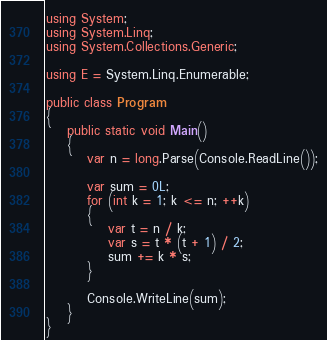Convert code to text. <code><loc_0><loc_0><loc_500><loc_500><_C#_>using System;
using System.Linq;
using System.Collections.Generic;

using E = System.Linq.Enumerable;

public class Program
{
    public static void Main()
    {
        var n = long.Parse(Console.ReadLine());

        var sum = 0L;
        for (int k = 1; k <= n; ++k)
        {
            var t = n / k;
            var s = t * (t + 1) / 2;
            sum += k * s;
        }

        Console.WriteLine(sum);
    }
}
</code> 